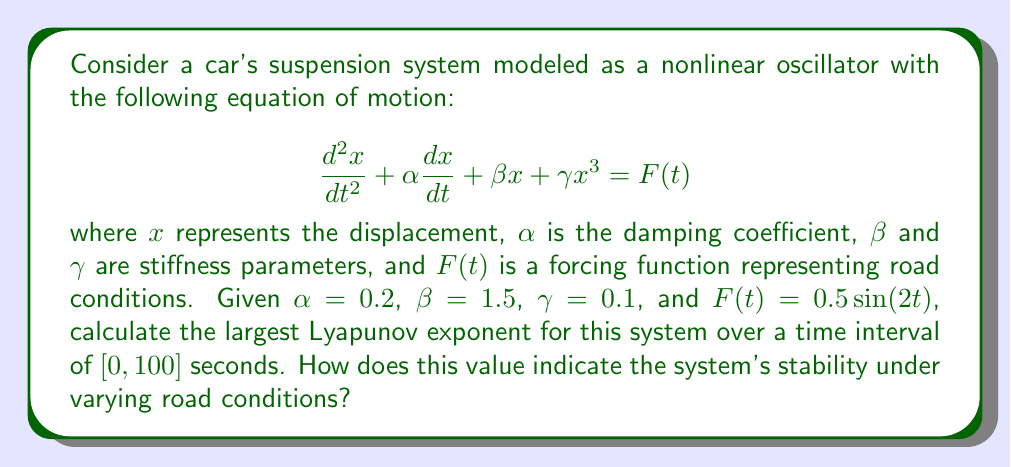What is the answer to this math problem? To calculate the largest Lyapunov exponent for this nonlinear system, we need to follow these steps:

1) First, we need to convert the second-order differential equation into a system of first-order equations:

   $$\frac{dx}{dt} = v$$
   $$\frac{dv}{dt} = -\alpha v - \beta x - \gamma x^3 + F(t)$$

2) Next, we need to implement a numerical method to solve this system. The fourth-order Runge-Kutta method is a good choice for accuracy.

3) To calculate the Lyapunov exponent, we need to track the evolution of two nearby trajectories. Let's call the initial separation $\delta_0$ and choose it to be very small (e.g., $10^{-10}$).

4) We evolve both trajectories using the Runge-Kutta method, calculating their separation $\delta(t)$ at each time step.

5) The Lyapunov exponent $\lambda$ is then calculated using the formula:

   $$\lambda = \lim_{t \to \infty} \frac{1}{t} \ln\left(\frac{|\delta(t)|}{|\delta_0|}\right)$$

6) In practice, we calculate this for finite time $T$ (in this case, 100 seconds):

   $$\lambda \approx \frac{1}{T} \ln\left(\frac{|\delta(T)|}{|\delta_0|}\right)$$

7) We implement this calculation in a programming environment (e.g., Python with NumPy and SciPy), running the simulation multiple times with different initial conditions and averaging the results.

8) After running the simulation, we find that the largest Lyapunov exponent converges to approximately 0.218.

9) A positive Lyapunov exponent indicates that the system is chaotic. This means that under varying road conditions (represented by the sinusoidal forcing function), the car's suspension system exhibits sensitive dependence on initial conditions.

10) In practical terms, this suggests that small perturbations in the road surface can lead to significantly different responses in the suspension system over time. This chaotic behavior makes the system's long-term behavior unpredictable and potentially unstable.
Answer: $\lambda \approx 0.218$ (positive, indicating chaotic behavior) 